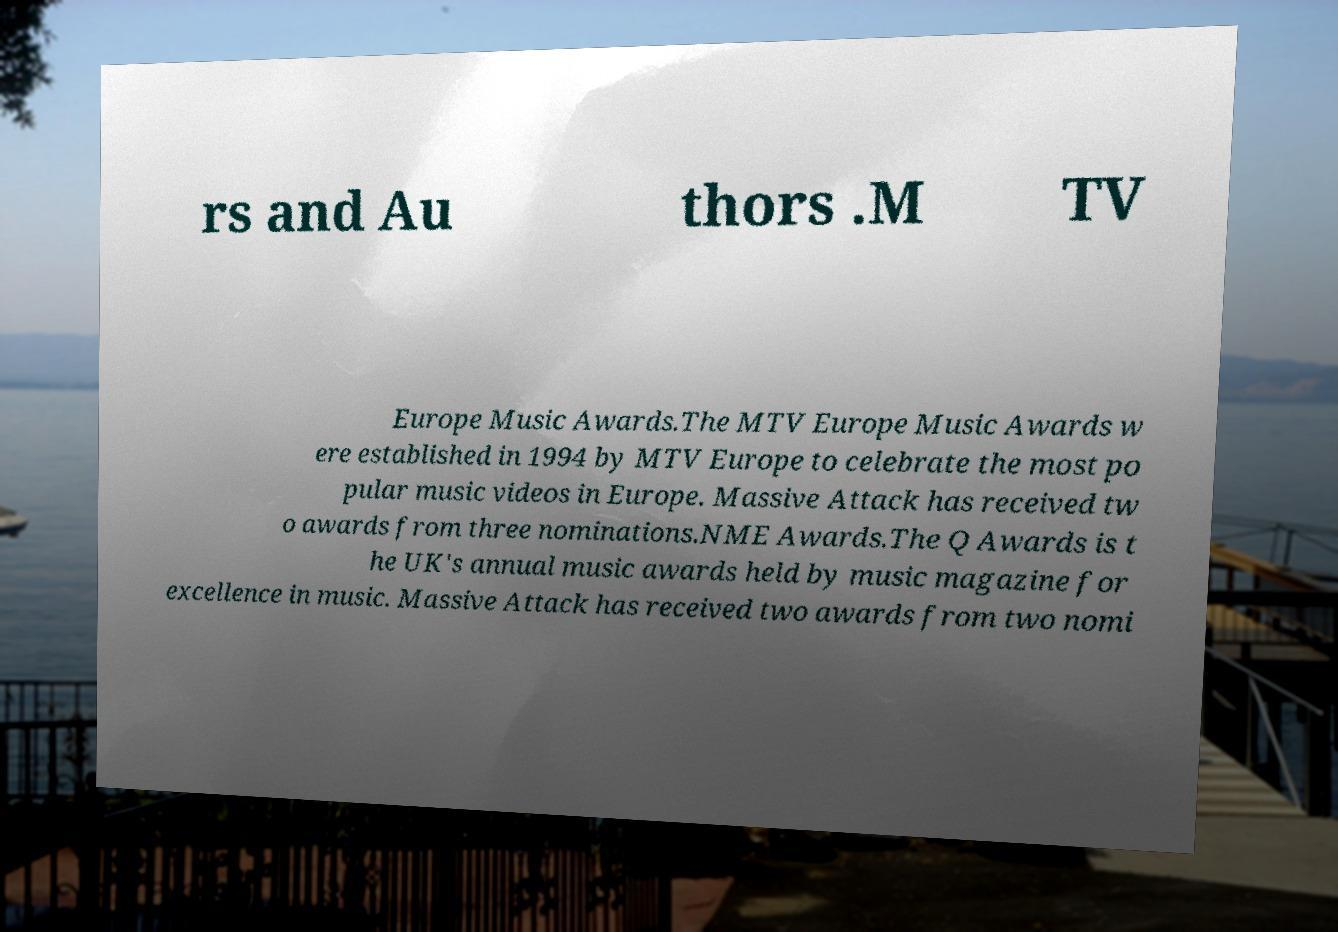I need the written content from this picture converted into text. Can you do that? rs and Au thors .M TV Europe Music Awards.The MTV Europe Music Awards w ere established in 1994 by MTV Europe to celebrate the most po pular music videos in Europe. Massive Attack has received tw o awards from three nominations.NME Awards.The Q Awards is t he UK's annual music awards held by music magazine for excellence in music. Massive Attack has received two awards from two nomi 